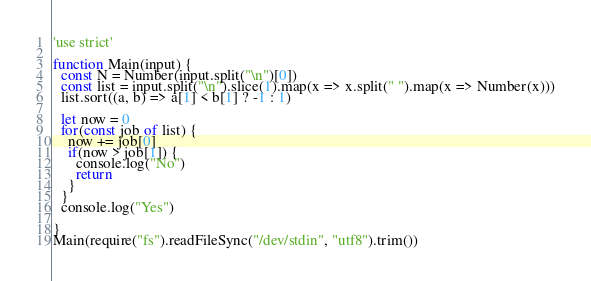<code> <loc_0><loc_0><loc_500><loc_500><_JavaScript_>'use strict'

function Main(input) {
  const N = Number(input.split("\n")[0])
  const list = input.split("\n").slice(1).map(x => x.split(" ").map(x => Number(x)))
  list.sort((a, b) => a[1] < b[1] ? -1 : 1)
  
  let now = 0
  for(const job of list) {
    now += job[0]
    if(now > job[1]) {
      console.log("No")
      return
    }
  }
  console.log("Yes")

}
Main(require("fs").readFileSync("/dev/stdin", "utf8").trim())</code> 